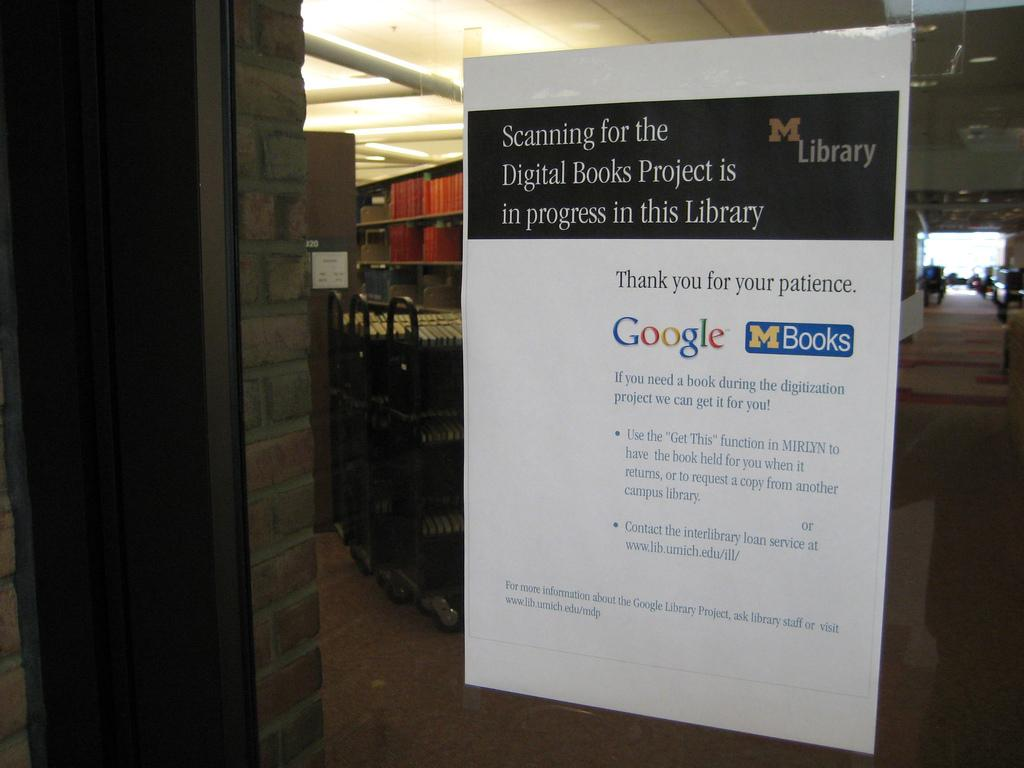<image>
Provide a brief description of the given image. A sign in the Michigan library says that scanning for the digital books project is in progress. 